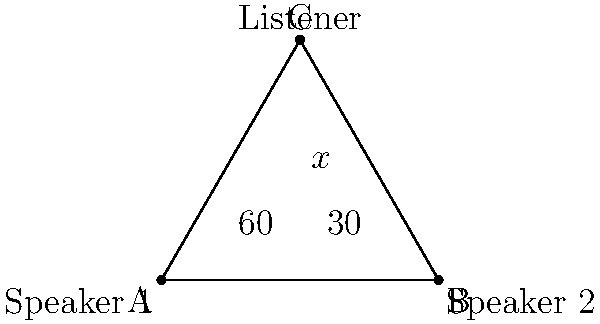At a grunge music festival, two speakers are placed 100 meters apart. A listener stands at a point forming an equilateral triangle with the speakers. If the sound waves from Speaker 1 hit the listener at a 60° angle, what is the angle (x°) at which the sound waves from both speakers intersect at the listener's position? Let's approach this step-by-step:

1) First, we recognize that the triangle formed is equilateral. This means all sides are equal and all angles are 60°.

2) In the diagram, we can see that the angle at A (Speaker 1) is divided into two parts: 60° and 30°. This is because:
   - The total angle in an equilateral triangle is 60°
   - The sound wave forms a 60° angle with the base
   - The remaining angle must be 30° (60° - 30° = 30°)

3) Now, let's focus on the angle x° at the listener's position (point C):
   - The total angle at C must be 60° (it's an equilateral triangle)
   - We know that one part of this angle is 30° (corresponding to the 30° angle at A)
   - Therefore, x° must be the remaining part of the 60° angle

4) We can set up an equation:
   $$x° + 30° = 60°$$

5) Solving for x:
   $$x° = 60° - 30° = 30°$$

Thus, the angle at which the sound waves intersect at the listener's position is 30°.
Answer: 30° 